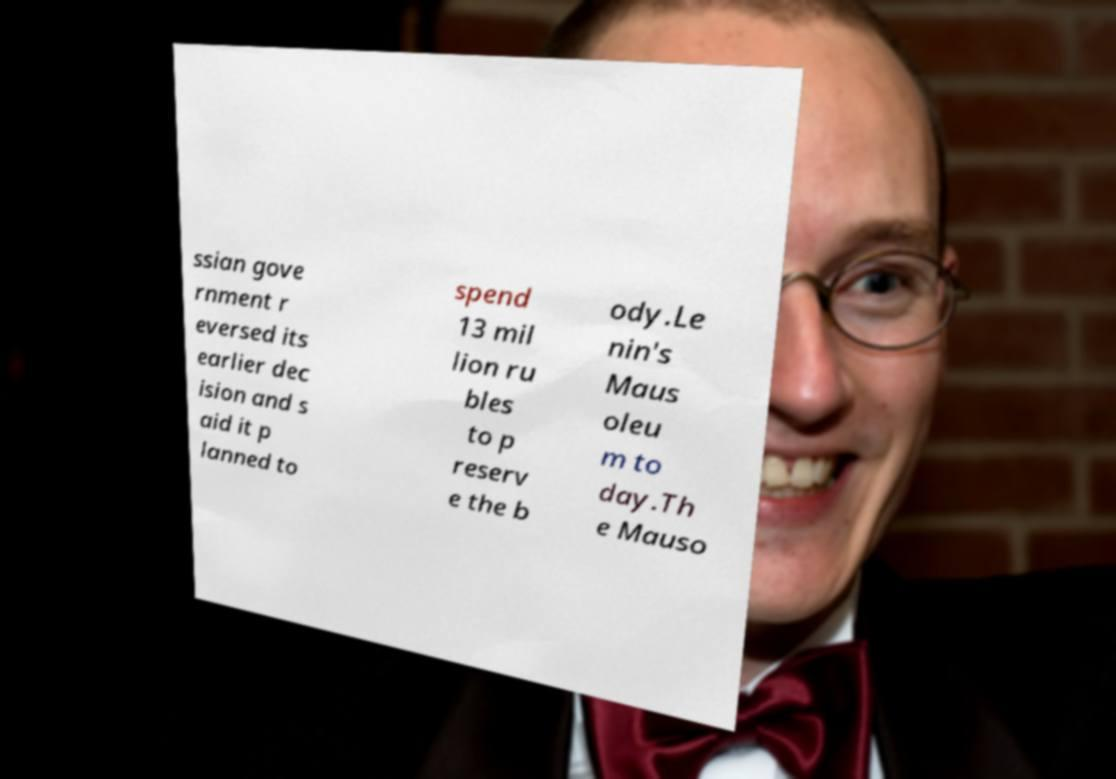Can you read and provide the text displayed in the image?This photo seems to have some interesting text. Can you extract and type it out for me? ssian gove rnment r eversed its earlier dec ision and s aid it p lanned to spend 13 mil lion ru bles to p reserv e the b ody.Le nin's Maus oleu m to day.Th e Mauso 